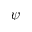Convert formula to latex. <formula><loc_0><loc_0><loc_500><loc_500>\psi</formula> 